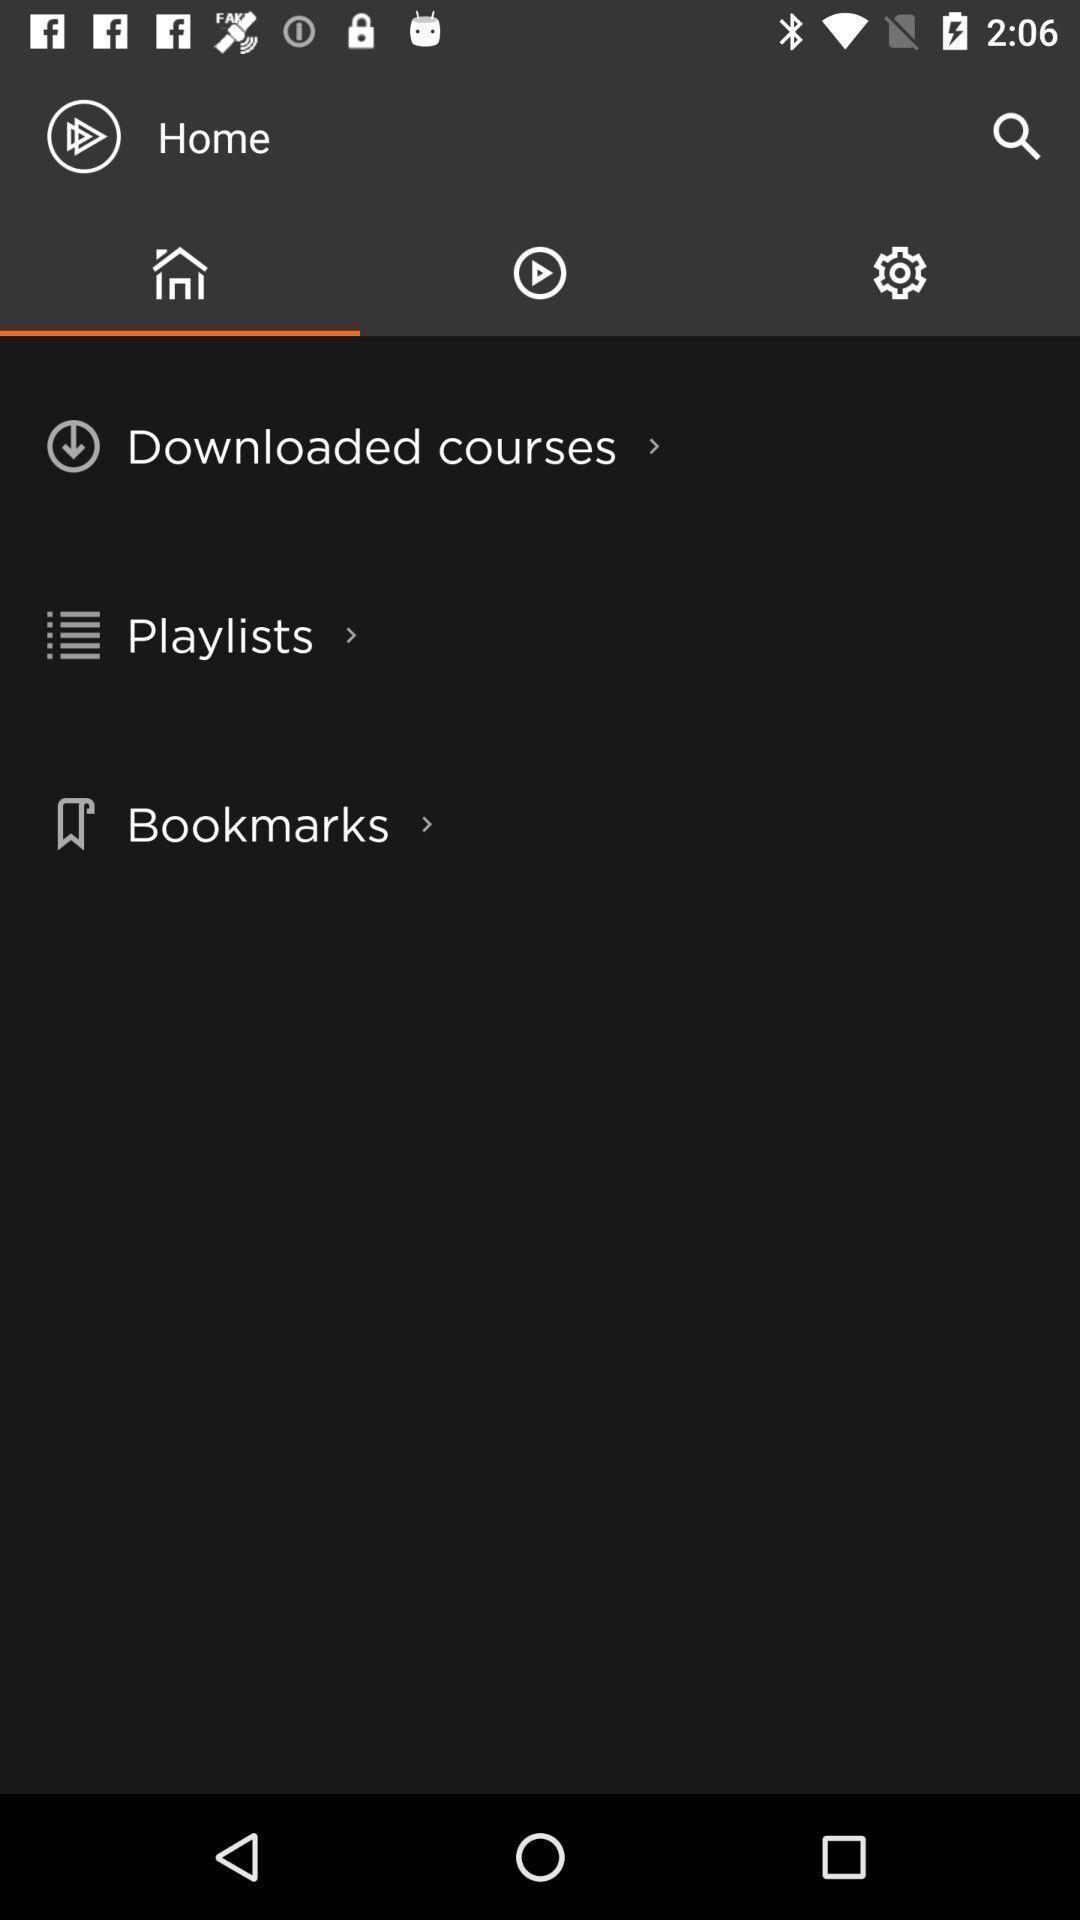Summarize the information in this screenshot. Screen showing home page with options. 